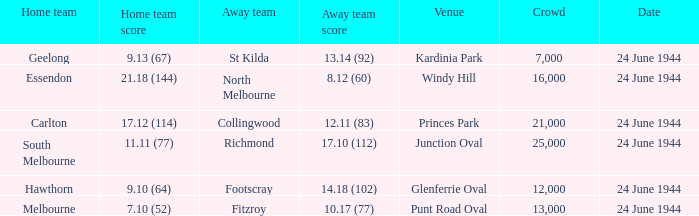When the Crowd was larger than 25,000. what was the Home Team score? None. 